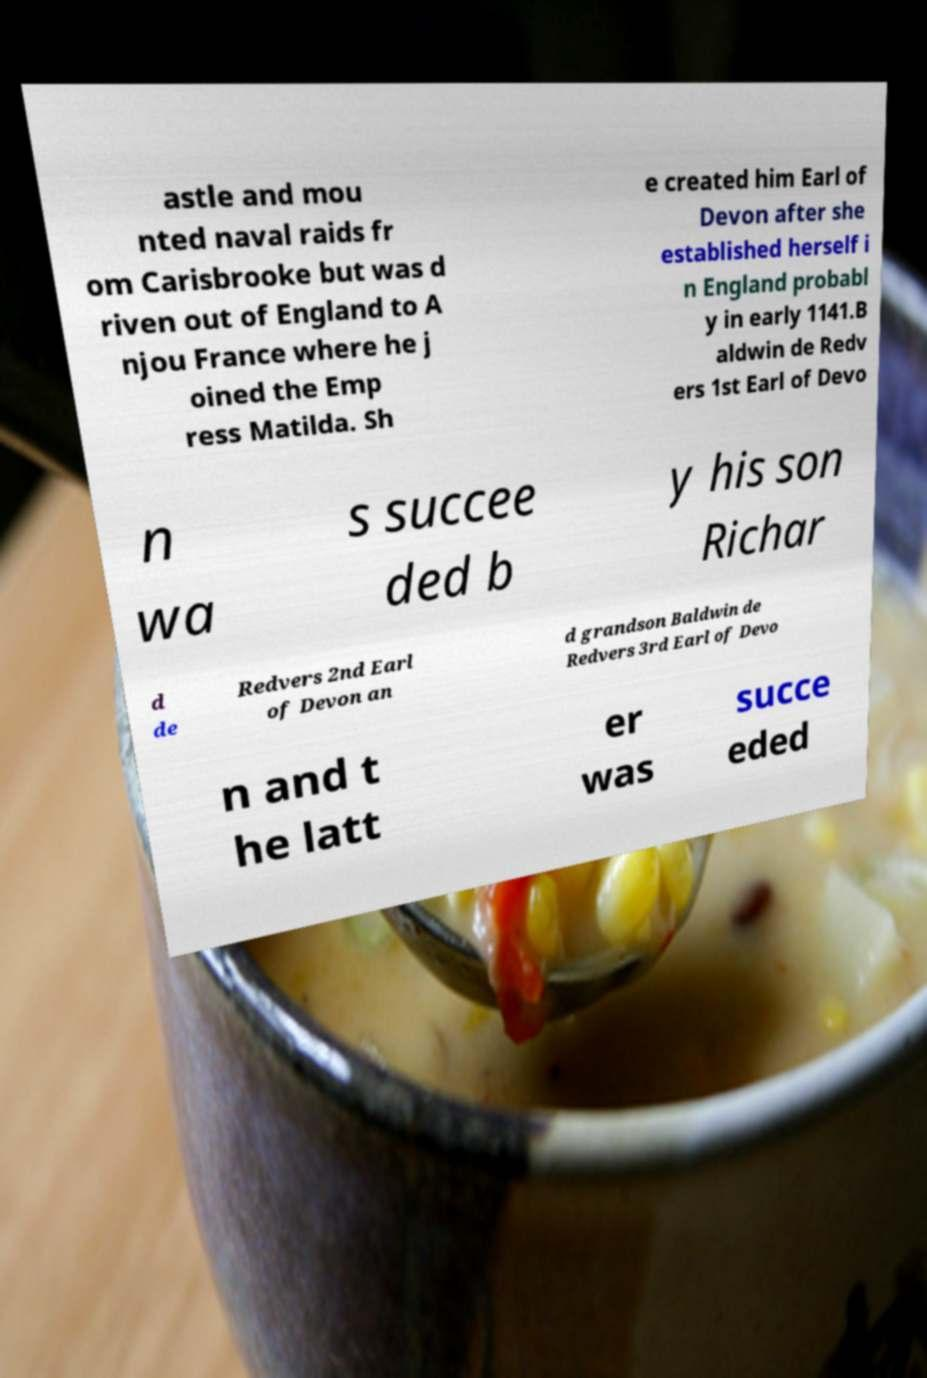Can you read and provide the text displayed in the image?This photo seems to have some interesting text. Can you extract and type it out for me? astle and mou nted naval raids fr om Carisbrooke but was d riven out of England to A njou France where he j oined the Emp ress Matilda. Sh e created him Earl of Devon after she established herself i n England probabl y in early 1141.B aldwin de Redv ers 1st Earl of Devo n wa s succee ded b y his son Richar d de Redvers 2nd Earl of Devon an d grandson Baldwin de Redvers 3rd Earl of Devo n and t he latt er was succe eded 